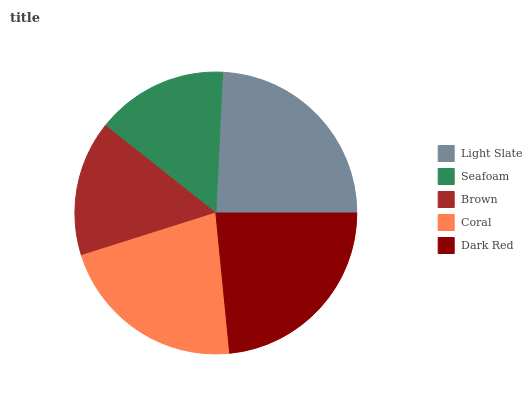Is Seafoam the minimum?
Answer yes or no. Yes. Is Light Slate the maximum?
Answer yes or no. Yes. Is Brown the minimum?
Answer yes or no. No. Is Brown the maximum?
Answer yes or no. No. Is Brown greater than Seafoam?
Answer yes or no. Yes. Is Seafoam less than Brown?
Answer yes or no. Yes. Is Seafoam greater than Brown?
Answer yes or no. No. Is Brown less than Seafoam?
Answer yes or no. No. Is Coral the high median?
Answer yes or no. Yes. Is Coral the low median?
Answer yes or no. Yes. Is Dark Red the high median?
Answer yes or no. No. Is Light Slate the low median?
Answer yes or no. No. 